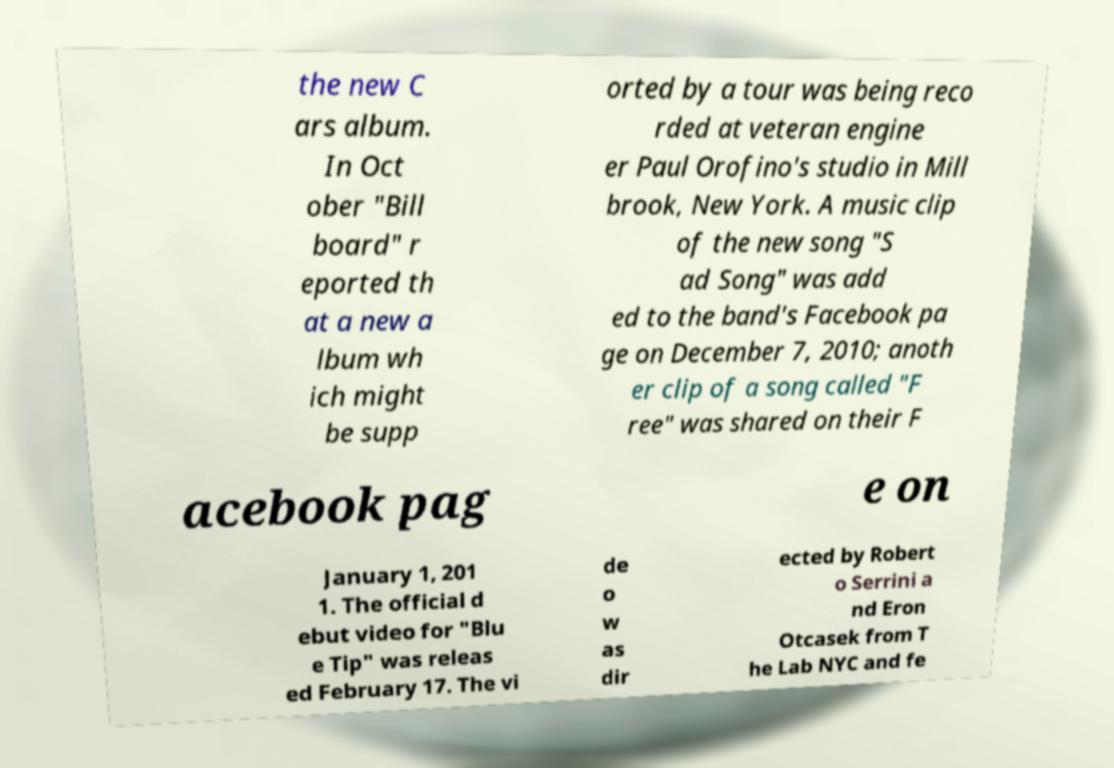Could you assist in decoding the text presented in this image and type it out clearly? the new C ars album. In Oct ober "Bill board" r eported th at a new a lbum wh ich might be supp orted by a tour was being reco rded at veteran engine er Paul Orofino's studio in Mill brook, New York. A music clip of the new song "S ad Song" was add ed to the band's Facebook pa ge on December 7, 2010; anoth er clip of a song called "F ree" was shared on their F acebook pag e on January 1, 201 1. The official d ebut video for "Blu e Tip" was releas ed February 17. The vi de o w as dir ected by Robert o Serrini a nd Eron Otcasek from T he Lab NYC and fe 